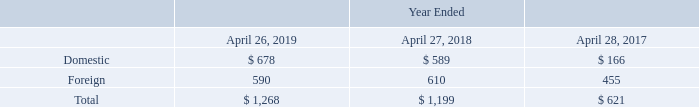14. Income Taxes
Income before income taxes is as follows (in millions):
What does the table show? Income before income taxes. What was the foreign income before income taxes in 2018?
Answer scale should be: million. 610. What was the total income before income taxes in 2017?
Answer scale should be: million. 621. What was the change in foreign income before income taxes between 2017 and 2018?
Answer scale should be: million. 610-455
Answer: 155. What was the change in foreign income before income taxes between 2018 and 2019?
Answer scale should be: million. 590-610
Answer: -20. What was the percentage change in the total income before income taxes between 2018 and 2019?
Answer scale should be: percent. (1,268-1,199)/1,199
Answer: 5.75. 